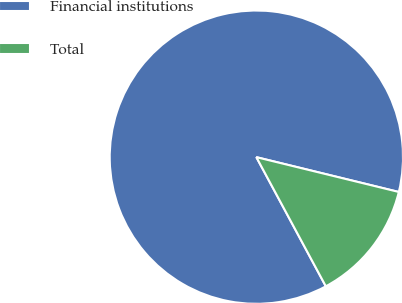Convert chart. <chart><loc_0><loc_0><loc_500><loc_500><pie_chart><fcel>Financial institutions<fcel>Total<nl><fcel>86.67%<fcel>13.33%<nl></chart> 